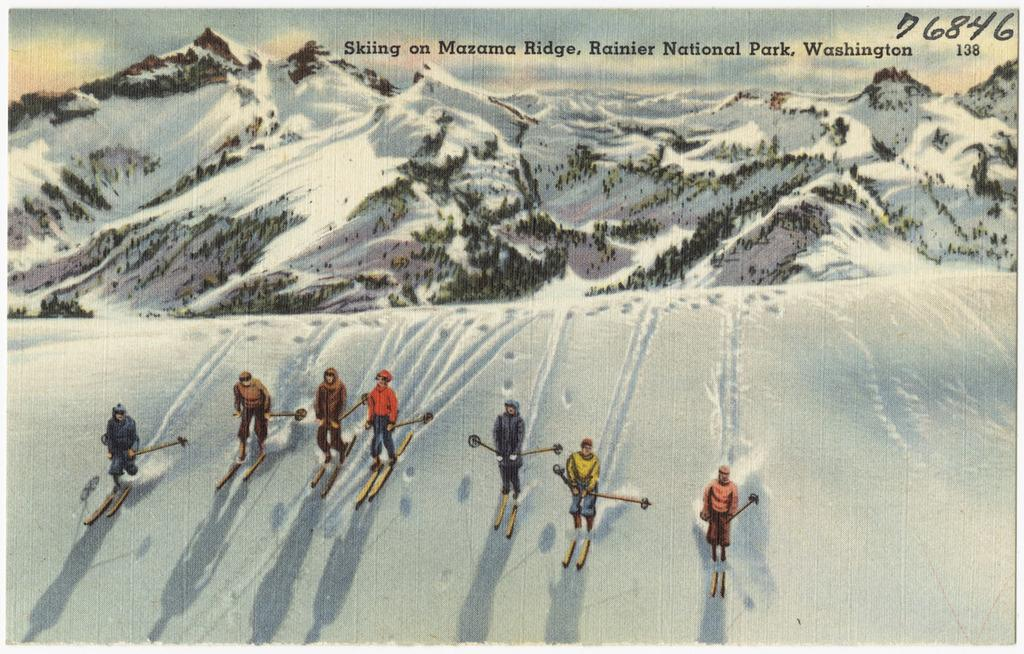What type of artwork is depicted in the image? The image is a painting. What activity are the persons engaged in within the painting? The persons are skiing on snow in the painting. What natural feature is visible in the background of the painting? There are mountains in the painting. Are there any words or phrases written on the painting? Yes, there are some texts written at the top of the painting. What type of work are the persons doing during recess in the image? There is no reference to work or recess in the image; it depicts persons skiing on snow in a painting. 